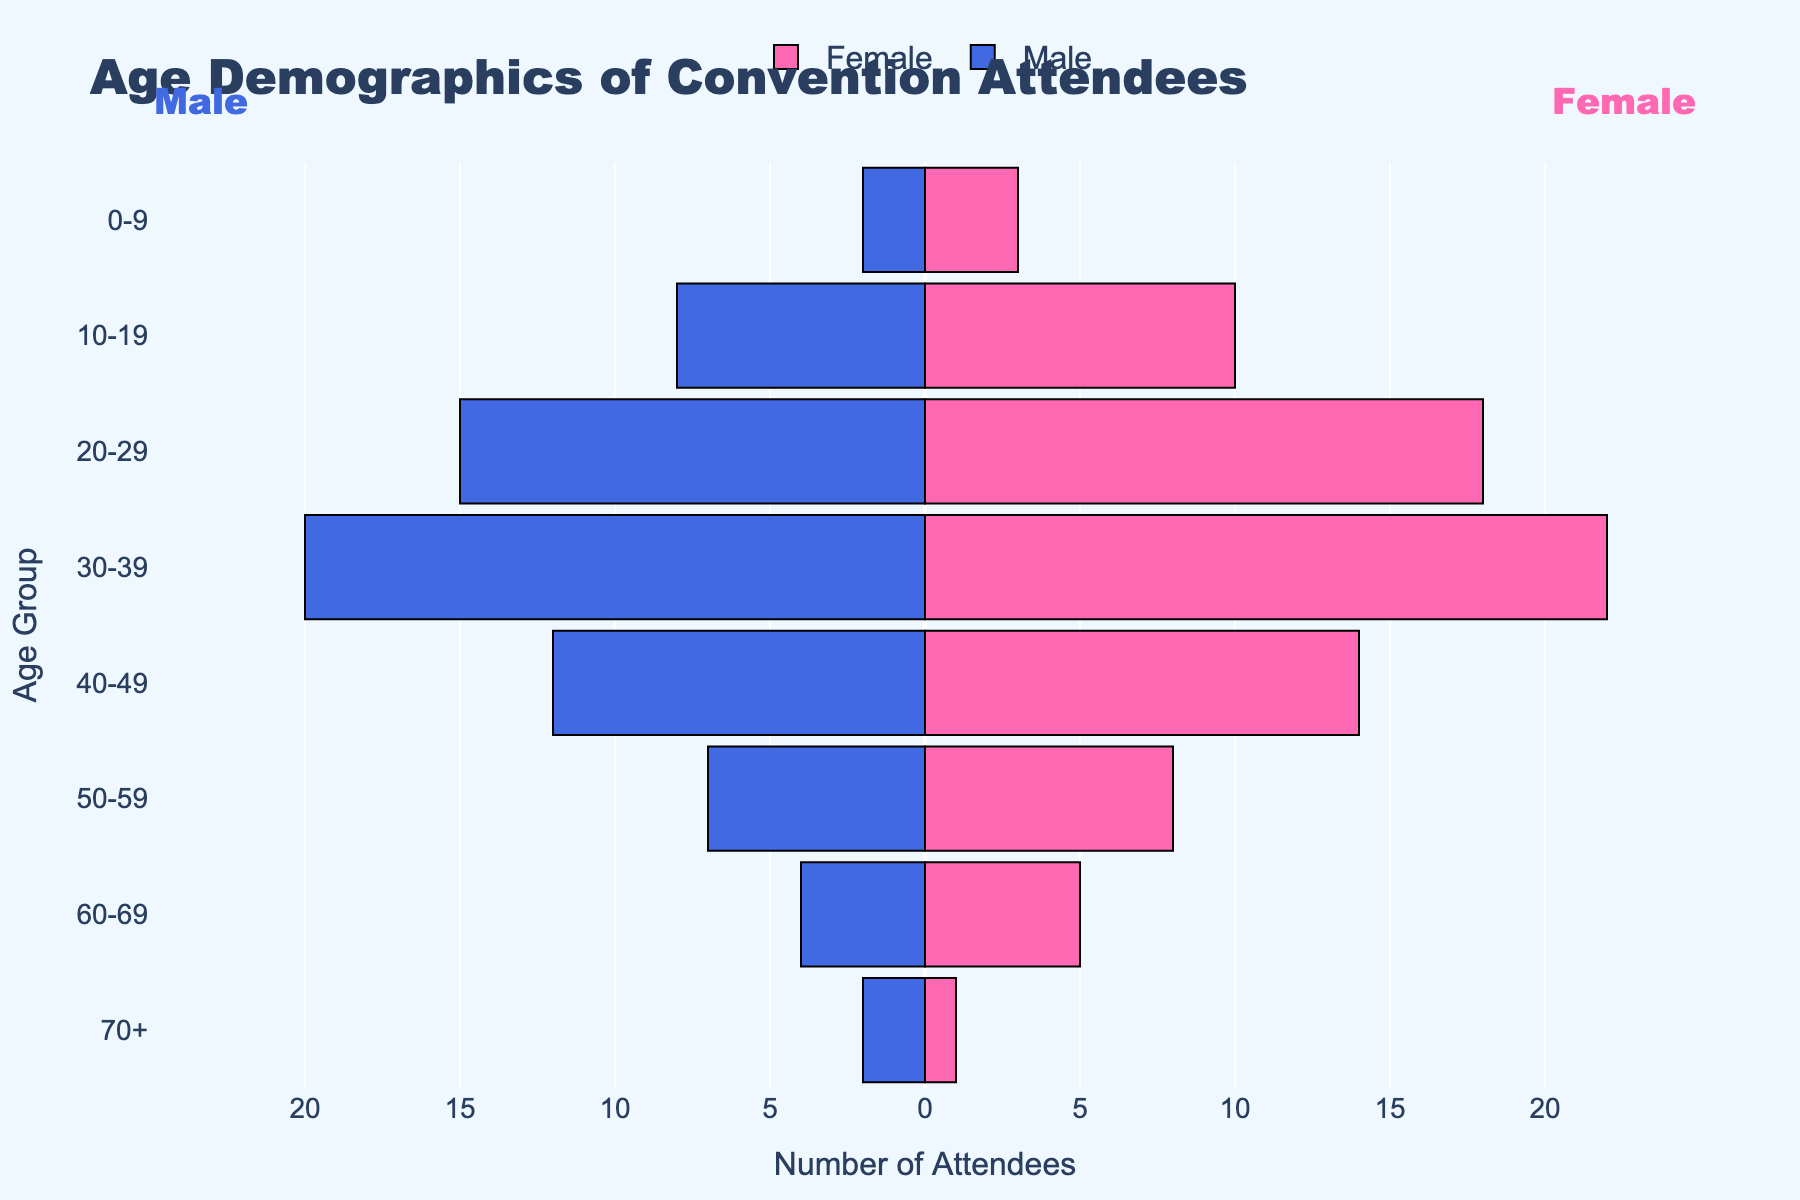What is the title of the figure? Look at the top of the figure where the title is located. The title is displayed prominently as "Age Demographics of Convention Attendees."
Answer: Age Demographics of Convention Attendees What is the age group with the highest number of female attendees? Find the bar that extends the furthest to the right on the Female (pink) side. This corresponds to the 30-39 age group, with 22 female attendees.
Answer: 30-39 Which age group has an equal number of male and female attendees? Compare the lengths of the blue and pink bars across all age groups. The 0-9 and 60-69 age groups each have nearly equal male and female attendees.
Answer: 0-9 and 60-69 How many more female attendees are there in the 20-29 age group compared to male attendees? Subtract the number of male attendees (15) from the number of female attendees (18) in the 20-29 age group. The result is 3 more female attendees.
Answer: 3 What is the total number of attendees in the 40-49 age group? Sum the number of male (12) and female (14) attendees in the 40-49 age group. The total is 26.
Answer: 26 In which age group is the difference between male and female attendees the largest? Calculate the absolute difference between male and female attendees for each age group. The largest difference occurs in the 30-39 age group, with a difference of 2 attendees (22 female - 20 male).
Answer: 30-39 Which gender has more attendees in the 10-19 age group and by how many? Compare the number of female attendees (10) to the number of male attendees (8) in the 10-19 age group. Females have 2 more attendees.
Answer: Females by 2 What is the total number of convention attendees across all age groups? Sum up all male and female attendees across each age group: (2+3) + (8+10) + (15+18) + (20+22) + (12+14) + (7+8) + (4+5) + (2+1). The total is 151 attendees.
Answer: 151 Which age group has the least number of total attendees? Add the number of male and female attendees for each age group and find the minimum. The 70+ age group has the least with 3 attendees (2 male + 1 female).
Answer: 70+ 